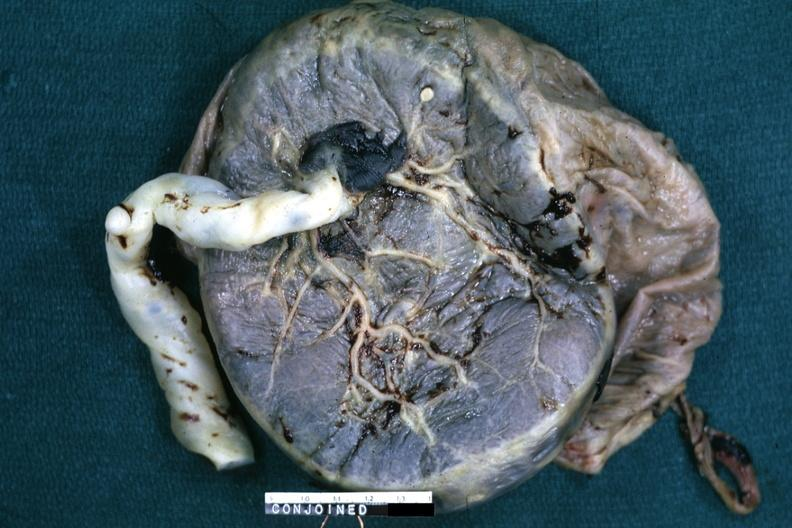s female reproductive present?
Answer the question using a single word or phrase. Yes 